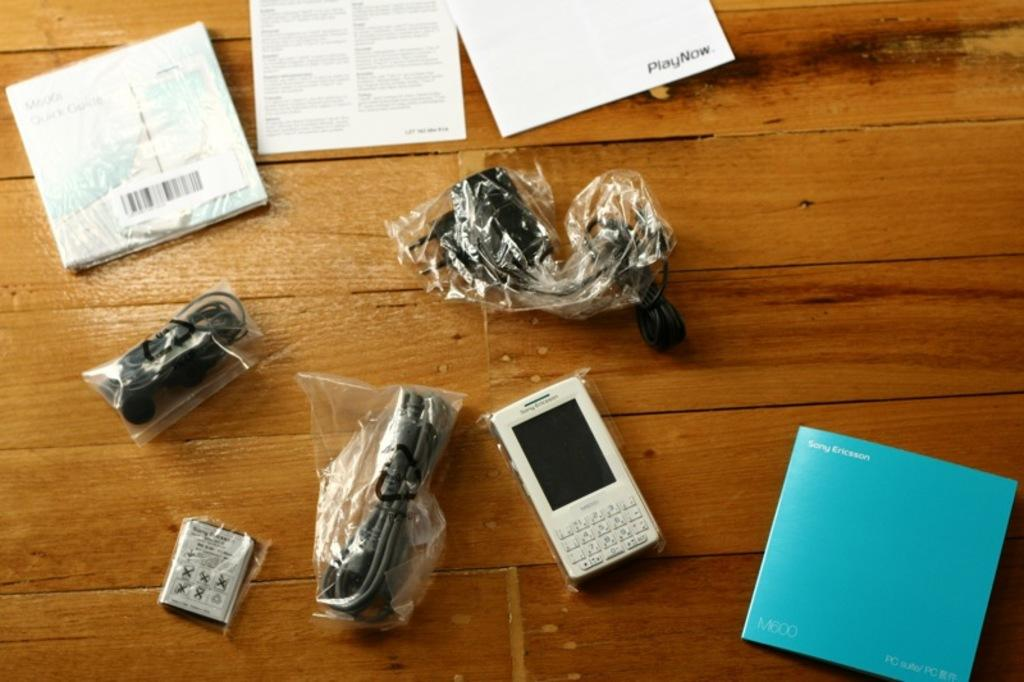<image>
Create a compact narrative representing the image presented. A blue booklet has Sony Ericsson written in white letters. 